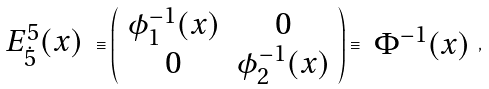Convert formula to latex. <formula><loc_0><loc_0><loc_500><loc_500>\begin{array} { c } E ^ { 5 } _ { \dot { 5 } } ( x ) \end{array} \equiv \left ( \begin{array} { c c } \phi _ { 1 } ^ { - 1 } ( x ) & 0 \\ 0 & \phi _ { 2 } ^ { - 1 } ( x ) \end{array} \right ) \equiv \begin{array} { c } \Phi ^ { - 1 } ( x ) \end{array} ,</formula> 